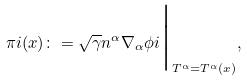Convert formula to latex. <formula><loc_0><loc_0><loc_500><loc_500>\pi i ( x ) \colon = \sqrt { \gamma } n ^ { \alpha } \nabla _ { \alpha } \phi i \Big | _ { T ^ { \alpha } = T ^ { \alpha } ( x ) } ,</formula> 